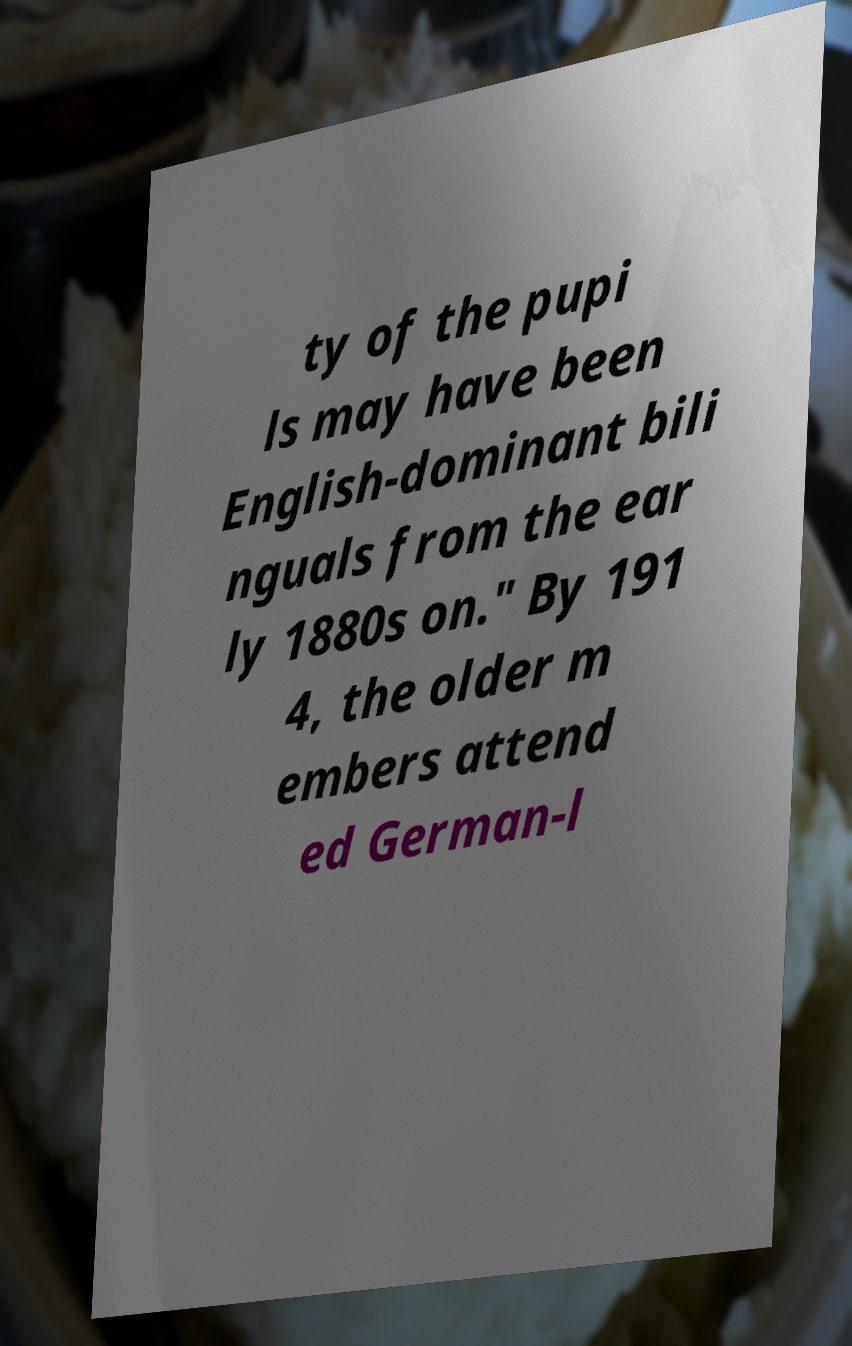Could you extract and type out the text from this image? ty of the pupi ls may have been English-dominant bili nguals from the ear ly 1880s on." By 191 4, the older m embers attend ed German-l 